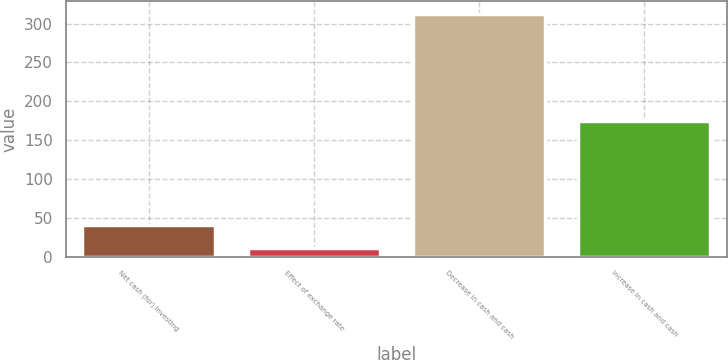Convert chart to OTSL. <chart><loc_0><loc_0><loc_500><loc_500><bar_chart><fcel>Net cash (for) investing<fcel>Effect of exchange rate<fcel>Decrease in cash and cash<fcel>Increase in cash and cash<nl><fcel>41.2<fcel>11<fcel>313<fcel>174<nl></chart> 